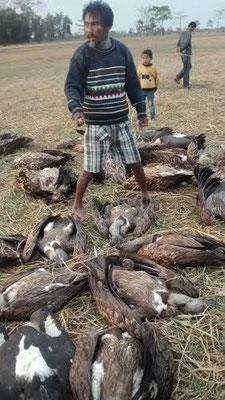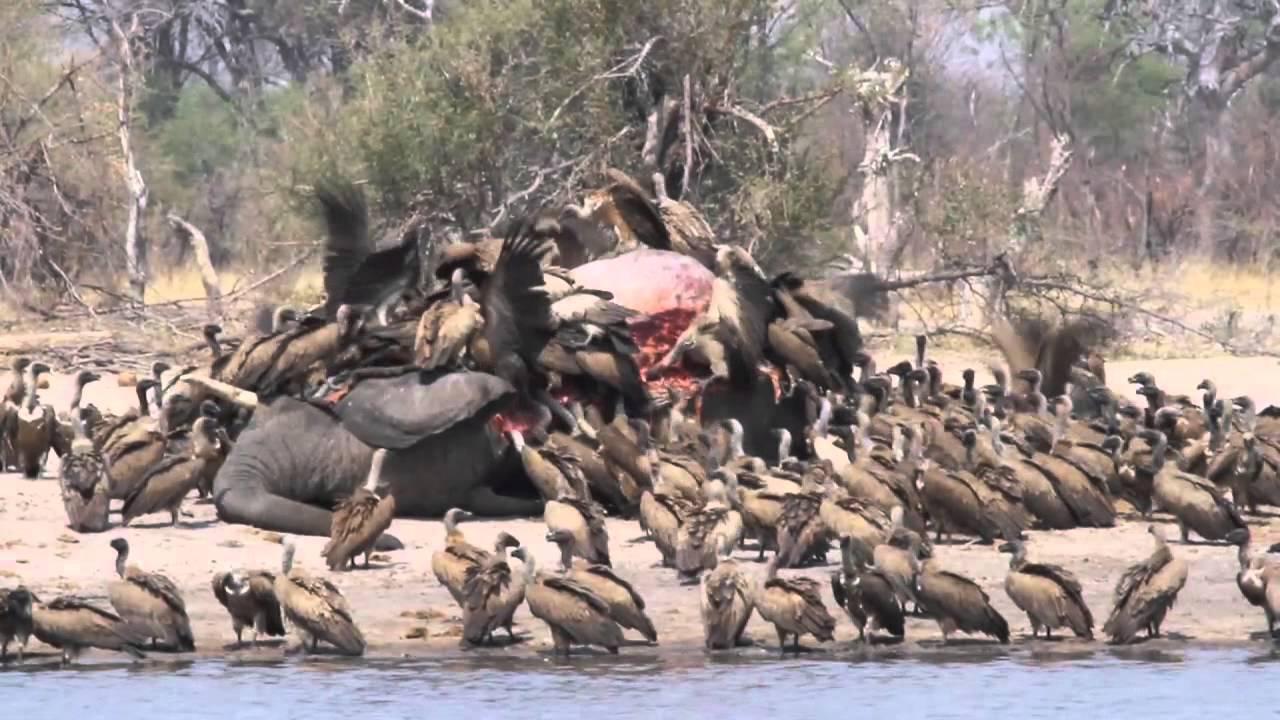The first image is the image on the left, the second image is the image on the right. Examine the images to the left and right. Is the description "In one of the images, the carrion birds are NOT eating anything at the moment." accurate? Answer yes or no. Yes. 